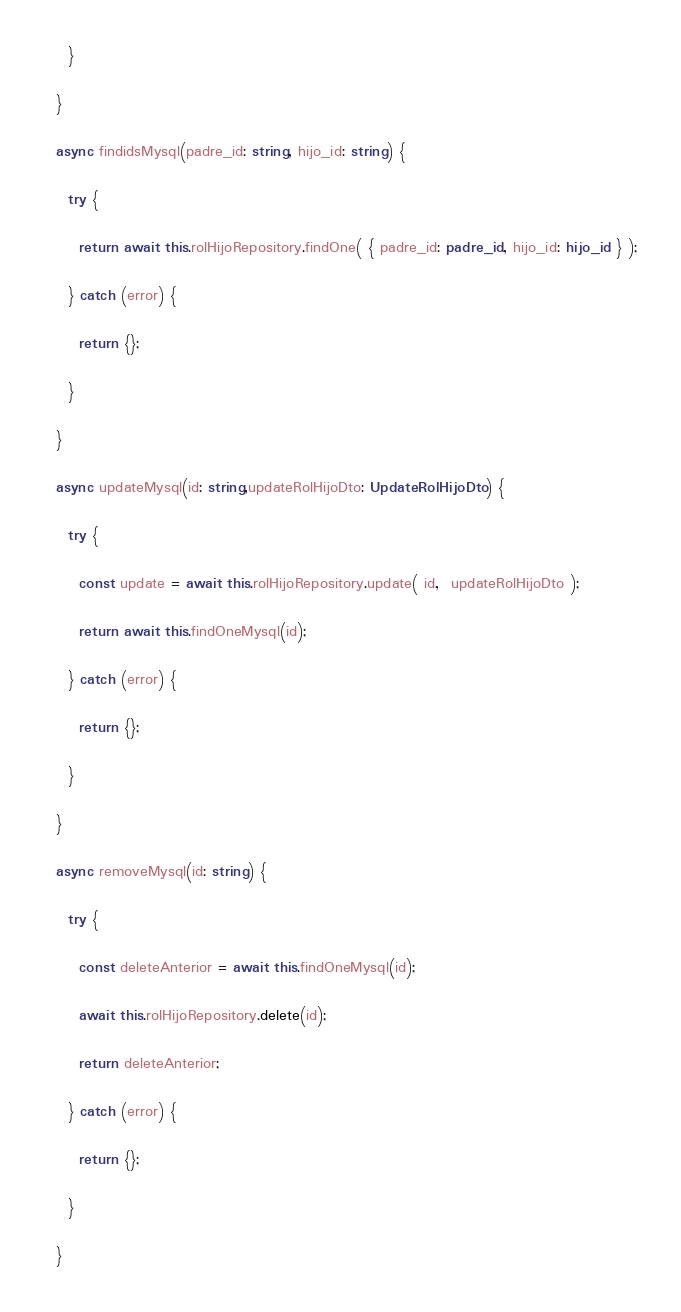Convert code to text. <code><loc_0><loc_0><loc_500><loc_500><_TypeScript_>    }

  }

  async findidsMysql(padre_id: string, hijo_id: string) {

    try {

      return await this.rolHijoRepository.findOne( { padre_id: padre_id, hijo_id: hijo_id } );

    } catch (error) {

      return {};

    }

  }

  async updateMysql(id: string,updateRolHijoDto: UpdateRolHijoDto) {

    try {

      const update = await this.rolHijoRepository.update( id,  updateRolHijoDto );

      return await this.findOneMysql(id);

    } catch (error) {

      return {};

    }

  }

  async removeMysql(id: string) {

    try {

      const deleteAnterior = await this.findOneMysql(id);

      await this.rolHijoRepository.delete(id);

      return deleteAnterior;

    } catch (error) {

      return {};

    }

  }
</code> 